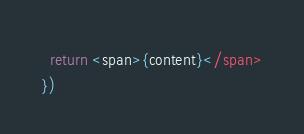<code> <loc_0><loc_0><loc_500><loc_500><_TypeScript_>  return <span>{content}</span>
})
</code> 